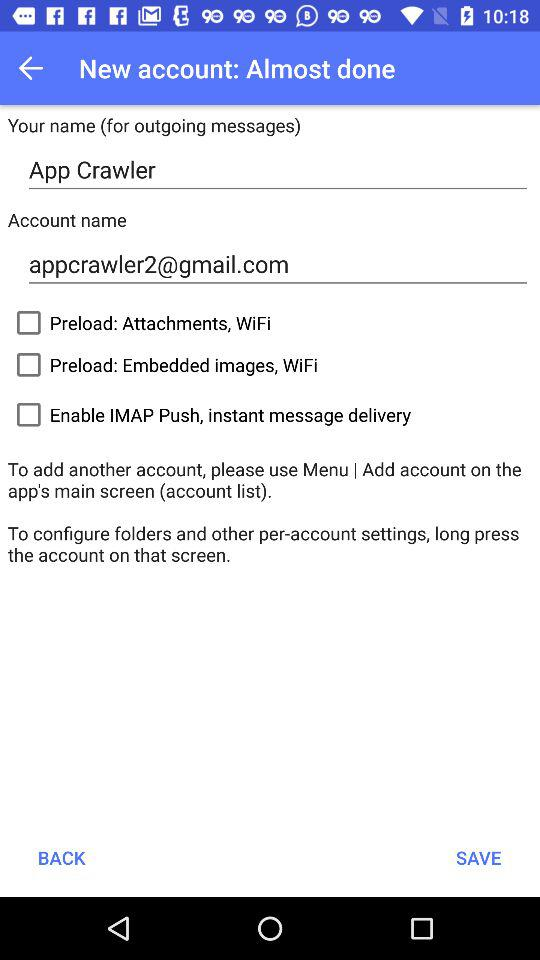What is the email address? The email address is appcrawler2@gmail.com. 